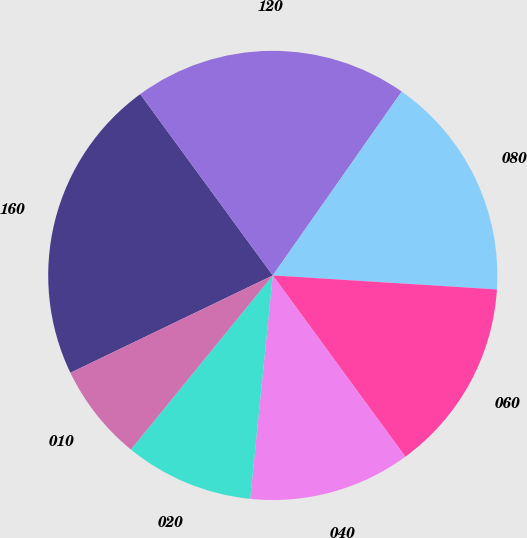Convert chart to OTSL. <chart><loc_0><loc_0><loc_500><loc_500><pie_chart><fcel>160<fcel>120<fcel>080<fcel>060<fcel>040<fcel>020<fcel>010<nl><fcel>22.09%<fcel>19.78%<fcel>16.26%<fcel>13.96%<fcel>11.65%<fcel>9.28%<fcel>6.98%<nl></chart> 